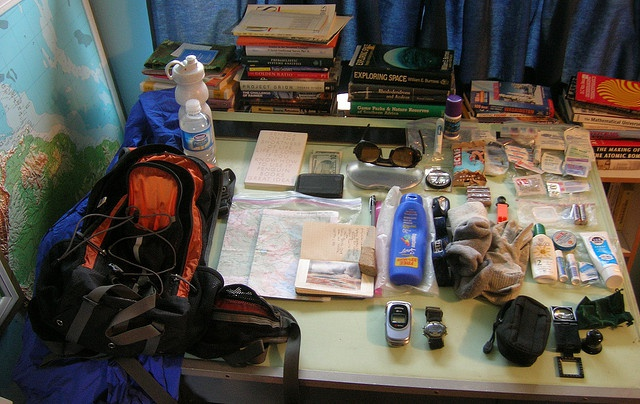Describe the objects in this image and their specific colors. I can see backpack in lightgray, black, maroon, and brown tones, handbag in lightgray, black, and gray tones, book in lightgray, tan, and darkgray tones, book in lightgray, black, olive, and gray tones, and handbag in lightgray, black, gray, darkgreen, and olive tones in this image. 